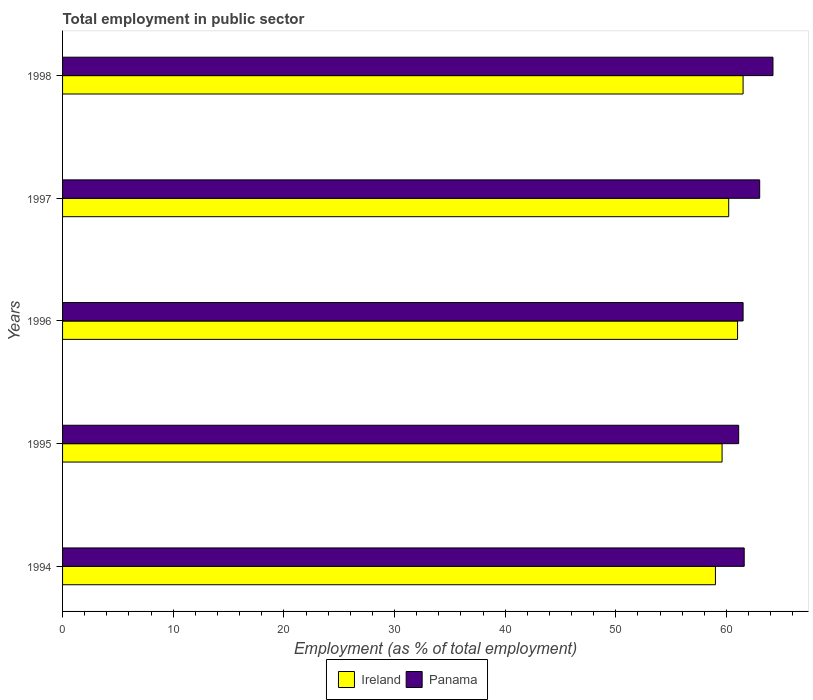How many different coloured bars are there?
Provide a short and direct response. 2. How many groups of bars are there?
Your answer should be very brief. 5. Are the number of bars per tick equal to the number of legend labels?
Make the answer very short. Yes. How many bars are there on the 3rd tick from the bottom?
Your answer should be very brief. 2. What is the employment in public sector in Panama in 1998?
Your answer should be very brief. 64.2. Across all years, what is the maximum employment in public sector in Panama?
Your response must be concise. 64.2. In which year was the employment in public sector in Ireland maximum?
Offer a terse response. 1998. What is the total employment in public sector in Panama in the graph?
Provide a short and direct response. 311.4. What is the difference between the employment in public sector in Panama in 1994 and the employment in public sector in Ireland in 1997?
Ensure brevity in your answer.  1.4. What is the average employment in public sector in Ireland per year?
Provide a succinct answer. 60.26. In the year 1995, what is the difference between the employment in public sector in Ireland and employment in public sector in Panama?
Your answer should be compact. -1.5. What is the ratio of the employment in public sector in Panama in 1994 to that in 1995?
Your response must be concise. 1.01. What is the difference between the highest and the lowest employment in public sector in Panama?
Offer a very short reply. 3.1. What does the 2nd bar from the top in 1997 represents?
Ensure brevity in your answer.  Ireland. What does the 2nd bar from the bottom in 1997 represents?
Offer a very short reply. Panama. How many bars are there?
Your response must be concise. 10. Are all the bars in the graph horizontal?
Provide a short and direct response. Yes. Does the graph contain any zero values?
Your answer should be very brief. No. Where does the legend appear in the graph?
Make the answer very short. Bottom center. What is the title of the graph?
Ensure brevity in your answer.  Total employment in public sector. Does "Austria" appear as one of the legend labels in the graph?
Your answer should be very brief. No. What is the label or title of the X-axis?
Offer a terse response. Employment (as % of total employment). What is the Employment (as % of total employment) in Panama in 1994?
Ensure brevity in your answer.  61.6. What is the Employment (as % of total employment) of Ireland in 1995?
Your answer should be very brief. 59.6. What is the Employment (as % of total employment) of Panama in 1995?
Give a very brief answer. 61.1. What is the Employment (as % of total employment) of Panama in 1996?
Your answer should be very brief. 61.5. What is the Employment (as % of total employment) in Ireland in 1997?
Your answer should be very brief. 60.2. What is the Employment (as % of total employment) in Ireland in 1998?
Provide a succinct answer. 61.5. What is the Employment (as % of total employment) in Panama in 1998?
Your answer should be very brief. 64.2. Across all years, what is the maximum Employment (as % of total employment) in Ireland?
Offer a very short reply. 61.5. Across all years, what is the maximum Employment (as % of total employment) in Panama?
Your answer should be very brief. 64.2. Across all years, what is the minimum Employment (as % of total employment) in Ireland?
Provide a short and direct response. 59. Across all years, what is the minimum Employment (as % of total employment) of Panama?
Ensure brevity in your answer.  61.1. What is the total Employment (as % of total employment) of Ireland in the graph?
Offer a terse response. 301.3. What is the total Employment (as % of total employment) of Panama in the graph?
Provide a short and direct response. 311.4. What is the difference between the Employment (as % of total employment) in Ireland in 1994 and that in 1995?
Keep it short and to the point. -0.6. What is the difference between the Employment (as % of total employment) of Panama in 1994 and that in 1995?
Your answer should be very brief. 0.5. What is the difference between the Employment (as % of total employment) of Ireland in 1994 and that in 1996?
Provide a succinct answer. -2. What is the difference between the Employment (as % of total employment) of Panama in 1994 and that in 1996?
Your answer should be compact. 0.1. What is the difference between the Employment (as % of total employment) in Ireland in 1994 and that in 1997?
Provide a succinct answer. -1.2. What is the difference between the Employment (as % of total employment) of Ireland in 1995 and that in 1996?
Your answer should be compact. -1.4. What is the difference between the Employment (as % of total employment) of Panama in 1995 and that in 1996?
Offer a terse response. -0.4. What is the difference between the Employment (as % of total employment) of Ireland in 1995 and that in 1998?
Give a very brief answer. -1.9. What is the difference between the Employment (as % of total employment) in Panama in 1995 and that in 1998?
Keep it short and to the point. -3.1. What is the difference between the Employment (as % of total employment) in Panama in 1996 and that in 1997?
Provide a short and direct response. -1.5. What is the difference between the Employment (as % of total employment) of Ireland in 1996 and that in 1998?
Provide a short and direct response. -0.5. What is the difference between the Employment (as % of total employment) in Ireland in 1997 and that in 1998?
Offer a terse response. -1.3. What is the difference between the Employment (as % of total employment) in Ireland in 1994 and the Employment (as % of total employment) in Panama in 1997?
Your answer should be compact. -4. What is the difference between the Employment (as % of total employment) in Ireland in 1994 and the Employment (as % of total employment) in Panama in 1998?
Your answer should be very brief. -5.2. What is the difference between the Employment (as % of total employment) of Ireland in 1995 and the Employment (as % of total employment) of Panama in 1997?
Keep it short and to the point. -3.4. What is the difference between the Employment (as % of total employment) of Ireland in 1996 and the Employment (as % of total employment) of Panama in 1997?
Make the answer very short. -2. What is the difference between the Employment (as % of total employment) in Ireland in 1997 and the Employment (as % of total employment) in Panama in 1998?
Your answer should be very brief. -4. What is the average Employment (as % of total employment) of Ireland per year?
Your response must be concise. 60.26. What is the average Employment (as % of total employment) of Panama per year?
Provide a succinct answer. 62.28. In the year 1994, what is the difference between the Employment (as % of total employment) in Ireland and Employment (as % of total employment) in Panama?
Keep it short and to the point. -2.6. In the year 1995, what is the difference between the Employment (as % of total employment) in Ireland and Employment (as % of total employment) in Panama?
Your answer should be compact. -1.5. In the year 1997, what is the difference between the Employment (as % of total employment) of Ireland and Employment (as % of total employment) of Panama?
Keep it short and to the point. -2.8. What is the ratio of the Employment (as % of total employment) in Panama in 1994 to that in 1995?
Offer a terse response. 1.01. What is the ratio of the Employment (as % of total employment) of Ireland in 1994 to that in 1996?
Your answer should be very brief. 0.97. What is the ratio of the Employment (as % of total employment) in Ireland in 1994 to that in 1997?
Offer a terse response. 0.98. What is the ratio of the Employment (as % of total employment) in Panama in 1994 to that in 1997?
Offer a very short reply. 0.98. What is the ratio of the Employment (as % of total employment) in Ireland in 1994 to that in 1998?
Provide a succinct answer. 0.96. What is the ratio of the Employment (as % of total employment) of Panama in 1994 to that in 1998?
Keep it short and to the point. 0.96. What is the ratio of the Employment (as % of total employment) in Ireland in 1995 to that in 1996?
Give a very brief answer. 0.98. What is the ratio of the Employment (as % of total employment) of Panama in 1995 to that in 1996?
Your response must be concise. 0.99. What is the ratio of the Employment (as % of total employment) of Panama in 1995 to that in 1997?
Provide a short and direct response. 0.97. What is the ratio of the Employment (as % of total employment) of Ireland in 1995 to that in 1998?
Keep it short and to the point. 0.97. What is the ratio of the Employment (as % of total employment) of Panama in 1995 to that in 1998?
Your response must be concise. 0.95. What is the ratio of the Employment (as % of total employment) of Ireland in 1996 to that in 1997?
Your answer should be compact. 1.01. What is the ratio of the Employment (as % of total employment) in Panama in 1996 to that in 1997?
Give a very brief answer. 0.98. What is the ratio of the Employment (as % of total employment) in Ireland in 1996 to that in 1998?
Give a very brief answer. 0.99. What is the ratio of the Employment (as % of total employment) of Panama in 1996 to that in 1998?
Your answer should be compact. 0.96. What is the ratio of the Employment (as % of total employment) of Ireland in 1997 to that in 1998?
Provide a short and direct response. 0.98. What is the ratio of the Employment (as % of total employment) in Panama in 1997 to that in 1998?
Offer a terse response. 0.98. What is the difference between the highest and the second highest Employment (as % of total employment) of Ireland?
Offer a terse response. 0.5. What is the difference between the highest and the second highest Employment (as % of total employment) in Panama?
Ensure brevity in your answer.  1.2. 